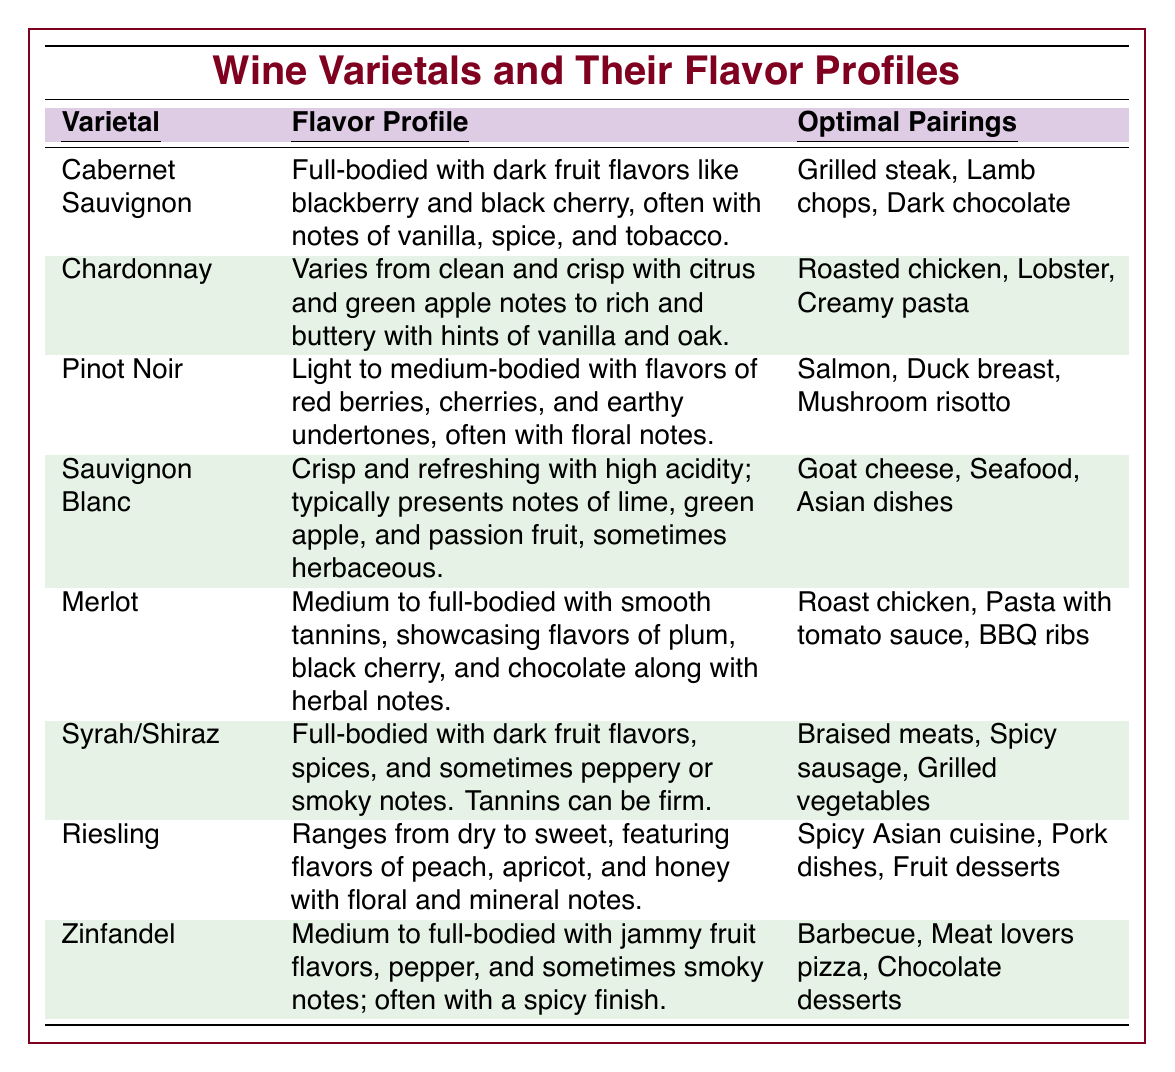What is the flavor profile of Chardonnay? The flavor profile of Chardonnay is described as varying from clean and crisp with citrus and green apple notes to rich and buttery with hints of vanilla and oak. This is found in the corresponding row of the table under Chardonnay.
Answer: Varies from clean and crisp with citrus and green apple notes to rich and buttery with hints of vanilla and oak Which wine varietal pairs best with BBQ ribs? BBQ ribs are paired best with Merlot, according to the third column in the table, which lists Merlot's optimal pairings.
Answer: Merlot Is Pinot Noir a full-bodied wine? The table categorizes Pinot Noir as light to medium-bodied, which directly answers this question by referring to its description in the flavor profile section.
Answer: No What are the optimal pairings for Riesling? The table lists the optimal pairings for Riesling as spicy Asian cuisine, pork dishes, and fruit desserts, which can be found in the corresponding row of the table.
Answer: Spicy Asian cuisine, pork dishes, fruit desserts Which wine varietal has the most robust flavor profile? Full-bodied wines, such as Cabernet Sauvignon and Syrah/Shiraz, have robust flavor profiles. Comparing the descriptions, both have dark fruit flavors, but Cabernet Sauvignon is emphasized more due to its specific flavors mentioned, making it the best candidate.
Answer: Cabernet Sauvignon How many varietals listed have chocolate as an optimal pairing? By reviewing the optimal pairings listed in the table, Cabernet Sauvignon and Zinfandel both feature chocolate in their pairings. Therefore, the count is two.
Answer: 2 Is there any wine that pairs well with both grilled steak and chocolate? Yes, according to the table, Cabernet Sauvignon pairs well with both grilled steak and dark chocolate as found in its optimal pairings column.
Answer: Yes What is the difference in flavor profiles between Chardonnay and Sauvignon Blanc? Chardonnay is described as varying from clean and crisp to rich and buttery with hints of oak, whereas Sauvignon Blanc is crisp and refreshing with high acidity and fruity notes. Therefore, the main difference lies in the complexity and richness associated with Chardonnay compared to the cleaner, fresher profile of Sauvignon Blanc.
Answer: Chardonnay is richer while Sauvignon Blanc is fresher Which wine varietals listed have flavors associated with spices? The varietals with flavors associated with spices are Syrah/Shiraz (with dark fruit flavors and spices) and Zinfandel (with pepper and sometimes smoky notes). Thus, both these varietals incorporate spice elements in their flavor profiles.
Answer: Syrah/Shiraz and Zinfandel Which wine varietal is recommended for pairing with lobster? The ideal pairing for lobster is Chardonnay as indicated in the corresponding row of optimal pairings for that varietal in the table.
Answer: Chardonnay 